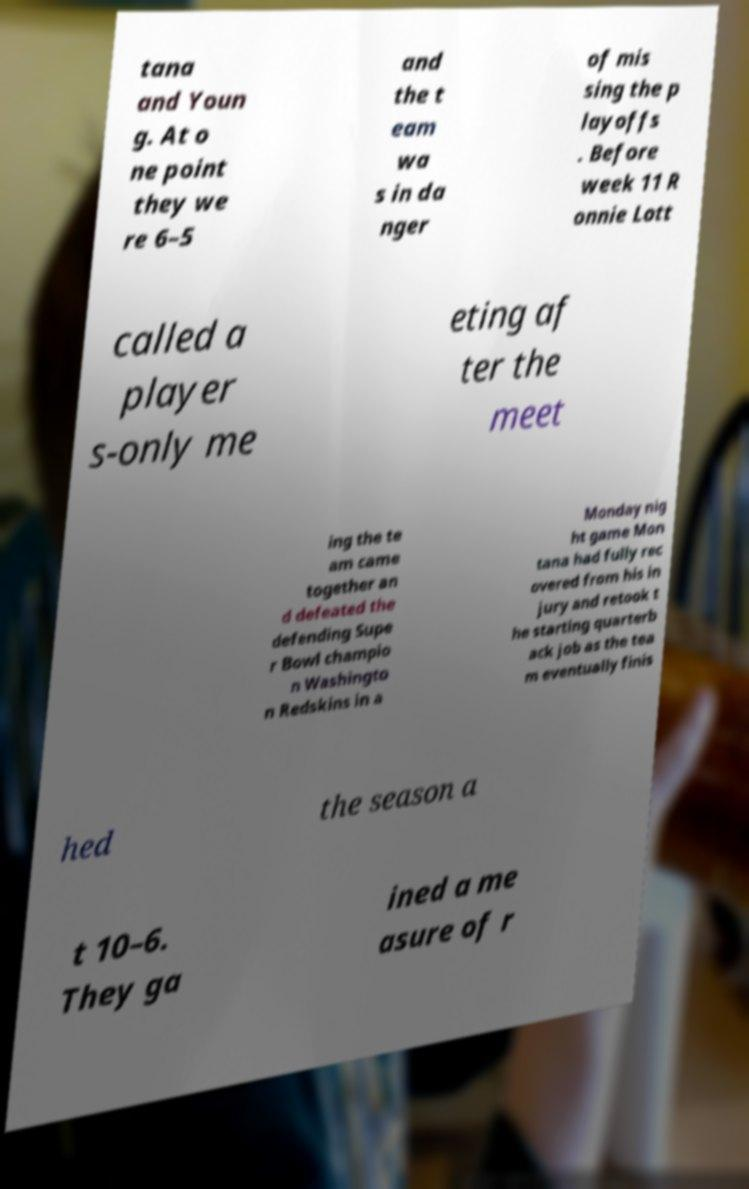Please read and relay the text visible in this image. What does it say? tana and Youn g. At o ne point they we re 6–5 and the t eam wa s in da nger of mis sing the p layoffs . Before week 11 R onnie Lott called a player s-only me eting af ter the meet ing the te am came together an d defeated the defending Supe r Bowl champio n Washingto n Redskins in a Monday nig ht game Mon tana had fully rec overed from his in jury and retook t he starting quarterb ack job as the tea m eventually finis hed the season a t 10–6. They ga ined a me asure of r 